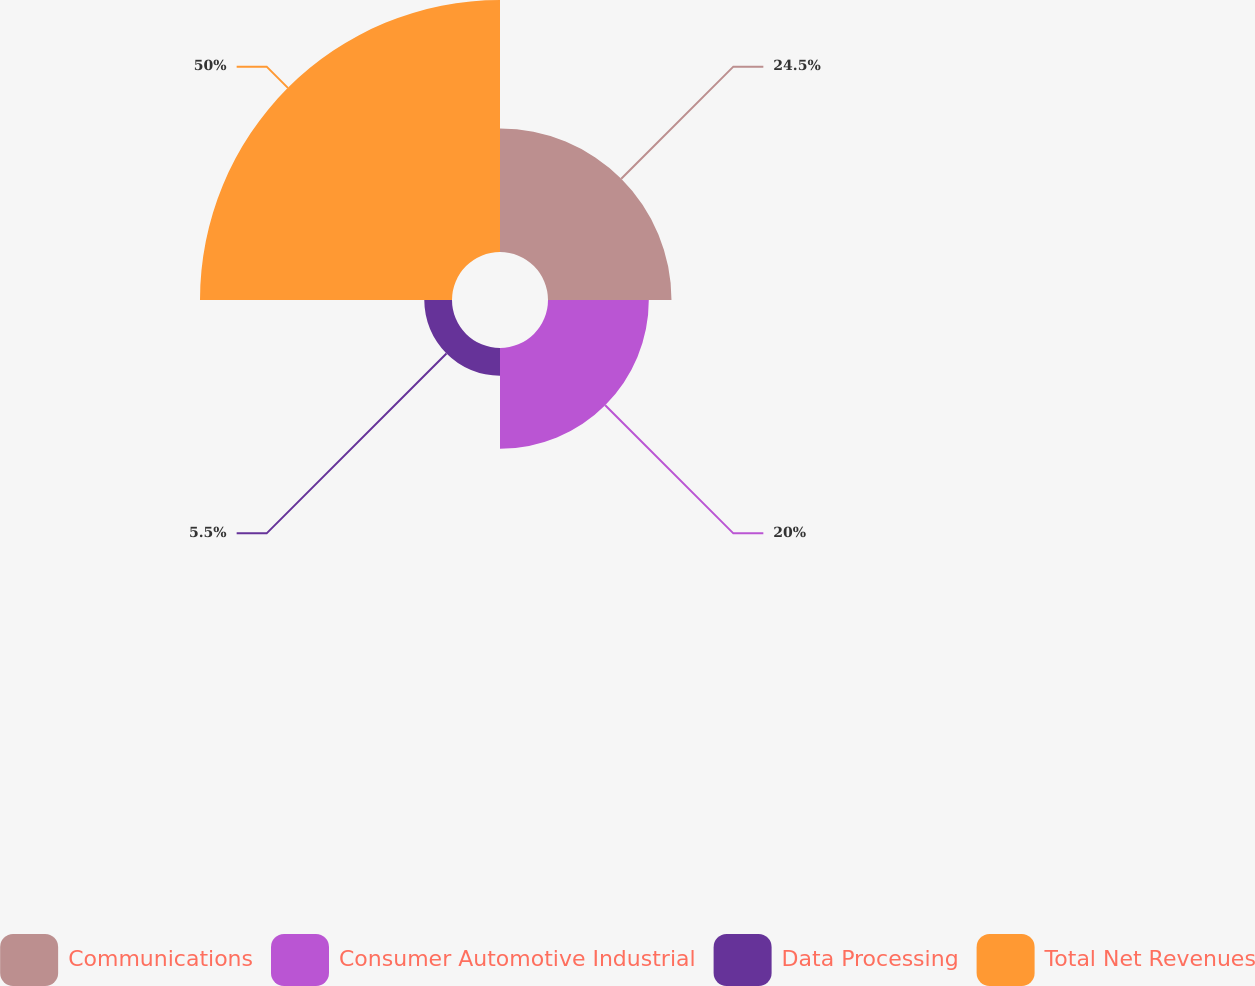Convert chart to OTSL. <chart><loc_0><loc_0><loc_500><loc_500><pie_chart><fcel>Communications<fcel>Consumer Automotive Industrial<fcel>Data Processing<fcel>Total Net Revenues<nl><fcel>24.5%<fcel>20.0%<fcel>5.5%<fcel>50.0%<nl></chart> 